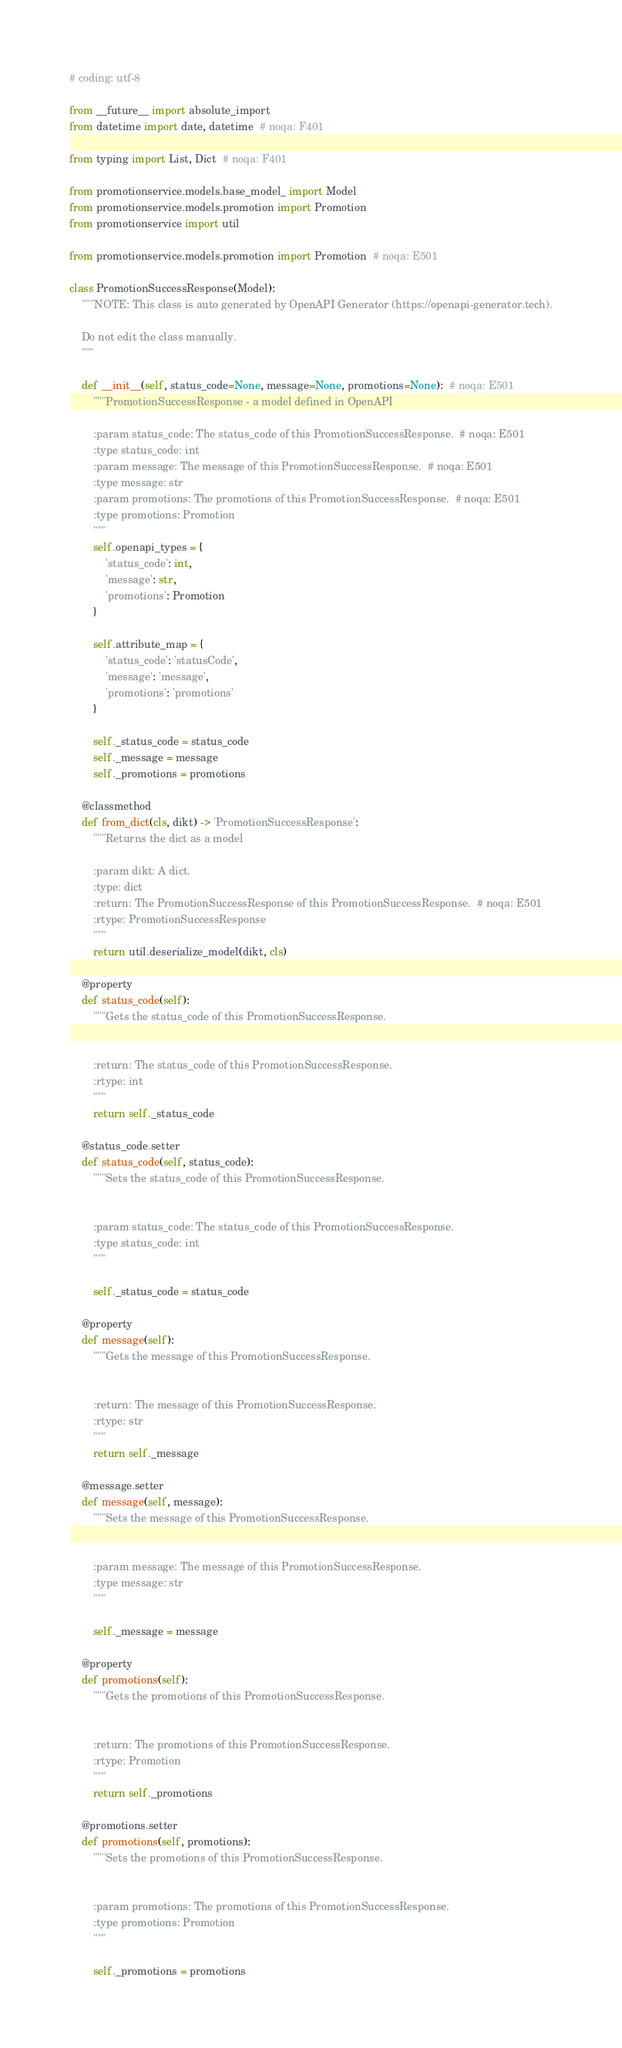<code> <loc_0><loc_0><loc_500><loc_500><_Python_># coding: utf-8

from __future__ import absolute_import
from datetime import date, datetime  # noqa: F401

from typing import List, Dict  # noqa: F401

from promotionservice.models.base_model_ import Model
from promotionservice.models.promotion import Promotion
from promotionservice import util

from promotionservice.models.promotion import Promotion  # noqa: E501

class PromotionSuccessResponse(Model):
    """NOTE: This class is auto generated by OpenAPI Generator (https://openapi-generator.tech).

    Do not edit the class manually.
    """

    def __init__(self, status_code=None, message=None, promotions=None):  # noqa: E501
        """PromotionSuccessResponse - a model defined in OpenAPI

        :param status_code: The status_code of this PromotionSuccessResponse.  # noqa: E501
        :type status_code: int
        :param message: The message of this PromotionSuccessResponse.  # noqa: E501
        :type message: str
        :param promotions: The promotions of this PromotionSuccessResponse.  # noqa: E501
        :type promotions: Promotion
        """
        self.openapi_types = {
            'status_code': int,
            'message': str,
            'promotions': Promotion
        }

        self.attribute_map = {
            'status_code': 'statusCode',
            'message': 'message',
            'promotions': 'promotions'
        }

        self._status_code = status_code
        self._message = message
        self._promotions = promotions

    @classmethod
    def from_dict(cls, dikt) -> 'PromotionSuccessResponse':
        """Returns the dict as a model

        :param dikt: A dict.
        :type: dict
        :return: The PromotionSuccessResponse of this PromotionSuccessResponse.  # noqa: E501
        :rtype: PromotionSuccessResponse
        """
        return util.deserialize_model(dikt, cls)

    @property
    def status_code(self):
        """Gets the status_code of this PromotionSuccessResponse.


        :return: The status_code of this PromotionSuccessResponse.
        :rtype: int
        """
        return self._status_code

    @status_code.setter
    def status_code(self, status_code):
        """Sets the status_code of this PromotionSuccessResponse.


        :param status_code: The status_code of this PromotionSuccessResponse.
        :type status_code: int
        """

        self._status_code = status_code

    @property
    def message(self):
        """Gets the message of this PromotionSuccessResponse.


        :return: The message of this PromotionSuccessResponse.
        :rtype: str
        """
        return self._message

    @message.setter
    def message(self, message):
        """Sets the message of this PromotionSuccessResponse.


        :param message: The message of this PromotionSuccessResponse.
        :type message: str
        """

        self._message = message

    @property
    def promotions(self):
        """Gets the promotions of this PromotionSuccessResponse.


        :return: The promotions of this PromotionSuccessResponse.
        :rtype: Promotion
        """
        return self._promotions

    @promotions.setter
    def promotions(self, promotions):
        """Sets the promotions of this PromotionSuccessResponse.


        :param promotions: The promotions of this PromotionSuccessResponse.
        :type promotions: Promotion
        """

        self._promotions = promotions
</code> 